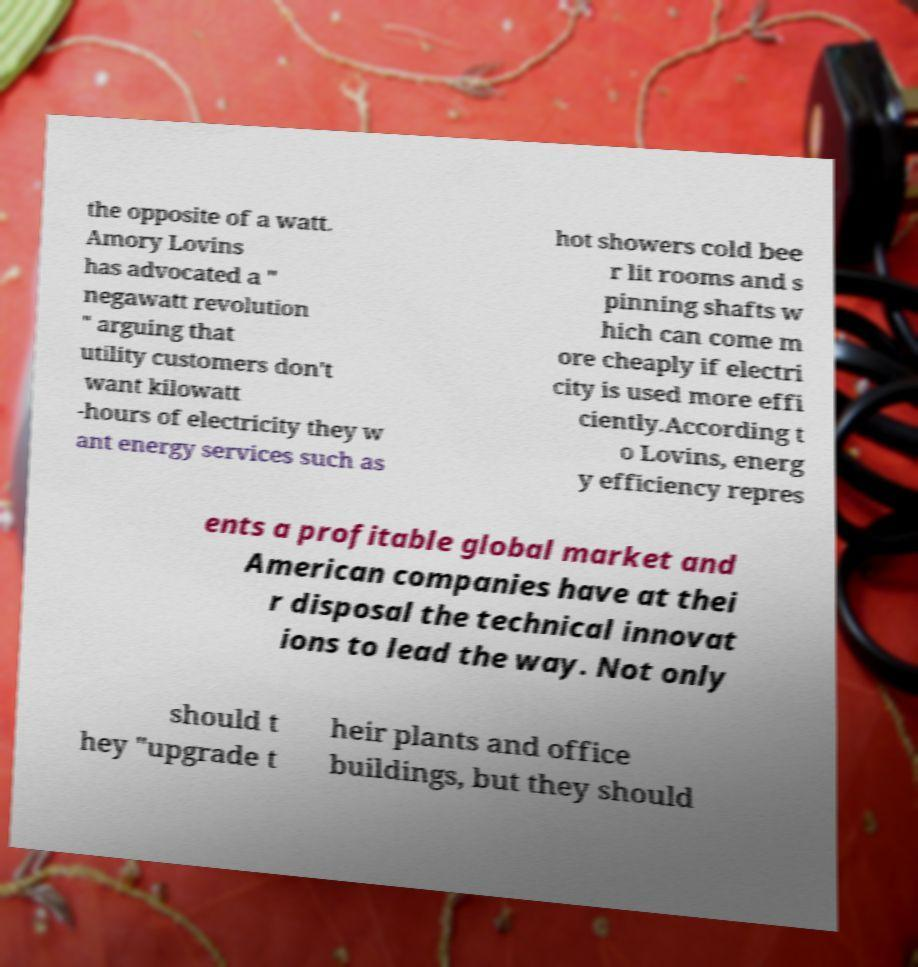Could you assist in decoding the text presented in this image and type it out clearly? the opposite of a watt. Amory Lovins has advocated a " negawatt revolution " arguing that utility customers don't want kilowatt -hours of electricity they w ant energy services such as hot showers cold bee r lit rooms and s pinning shafts w hich can come m ore cheaply if electri city is used more effi ciently.According t o Lovins, energ y efficiency repres ents a profitable global market and American companies have at thei r disposal the technical innovat ions to lead the way. Not only should t hey "upgrade t heir plants and office buildings, but they should 